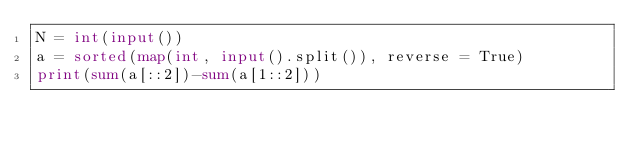<code> <loc_0><loc_0><loc_500><loc_500><_Python_>N = int(input())
a = sorted(map(int, input().split()), reverse = True)
print(sum(a[::2])-sum(a[1::2]))</code> 